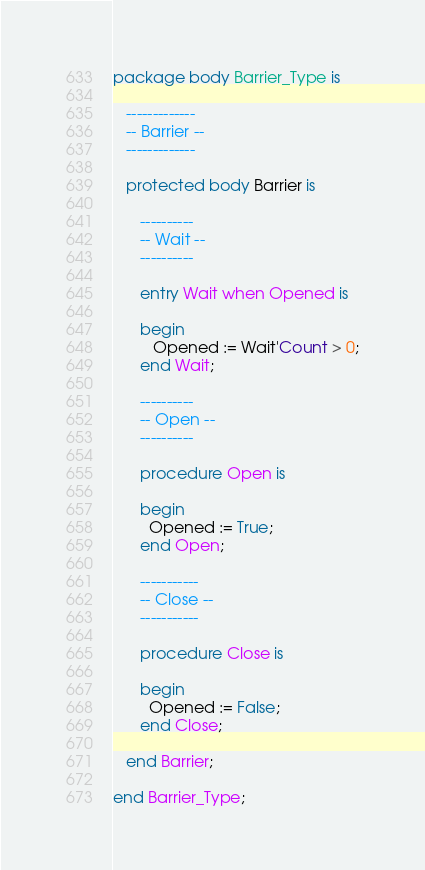Convert code to text. <code><loc_0><loc_0><loc_500><loc_500><_Ada_>package body Barrier_Type is

   -------------
   -- Barrier --
   -------------

   protected body Barrier is

      ----------
      -- Wait --
      ----------

      entry Wait when Opened is

      begin
         Opened := Wait'Count > 0;
      end Wait;

      ----------
      -- Open --
      ----------

      procedure Open is

      begin
        Opened := True;
      end Open;

      -----------
      -- Close --
      -----------

      procedure Close is

      begin
        Opened := False;
      end Close;

   end Barrier;

end Barrier_Type;
</code> 